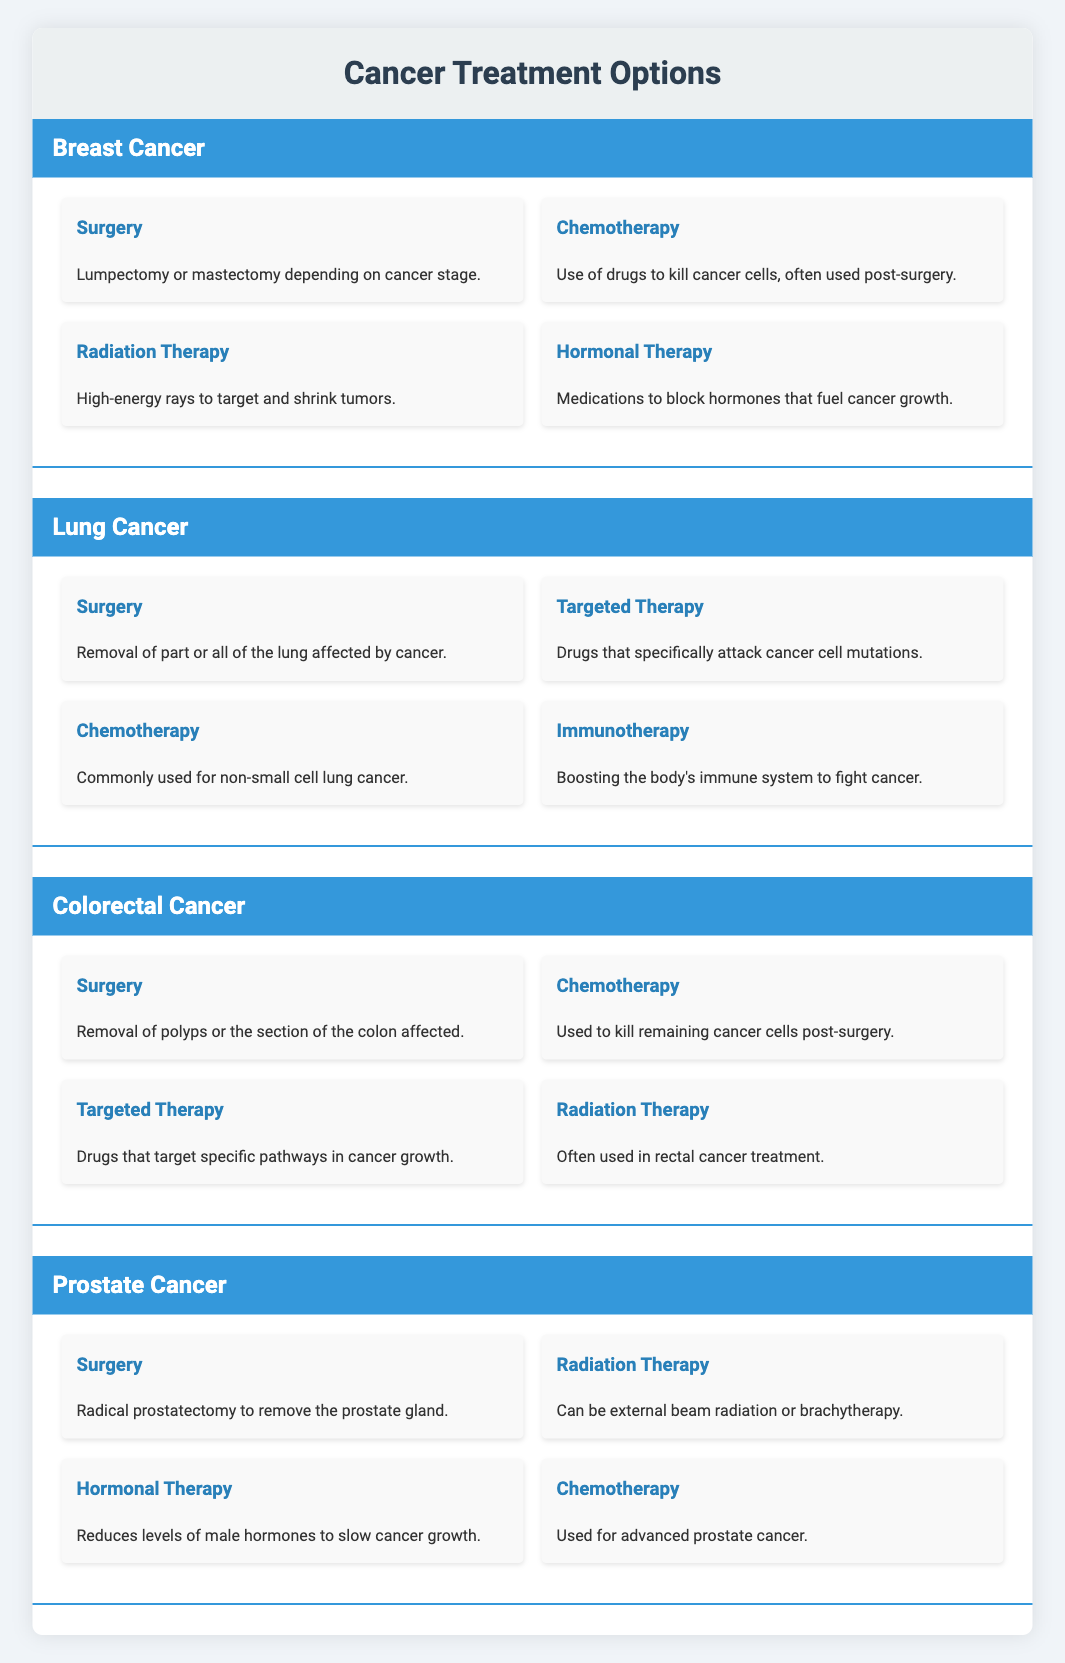What treatment options are available for Breast Cancer? The table lists four treatments under Breast Cancer: Surgery, Chemotherapy, Radiation Therapy, and Hormonal Therapy.
Answer: Surgery, Chemotherapy, Radiation Therapy, Hormonal Therapy Is Radiation Therapy included in the treatment options for Lung Cancer? Looking under the Lung Cancer section, the available treatments are Surgery, Targeted Therapy, Chemotherapy, and Immunotherapy. Radiation Therapy is not listed here, so the answer is no.
Answer: No How many treatments are listed for Colorectal Cancer? The table shows four treatments for Colorectal Cancer, which are Surgery, Chemotherapy, Targeted Therapy, and Radiation Therapy.
Answer: Four Which cancer type has immunotherapy as a treatment option? By checking the list of treatments under each cancer type, it is clear that Immunotherapy is associated with Lung Cancer only.
Answer: Lung Cancer Is Chemotherapy a treatment for both Breast Cancer and Prostate Cancer? Breast Cancer has Chemotherapy listed as a treatment, and Prostate Cancer also includes it as one of the treatment options. Therefore, the answer is yes.
Answer: Yes What is the difference in the number of treatment options between Lung Cancer and Prostate Cancer? Lung Cancer has four treatments: Surgery, Targeted Therapy, Chemotherapy, and Immunotherapy. Prostate Cancer also has four treatments: Surgery, Radiation Therapy, Hormonal Therapy, and Chemotherapy. The differences in the number of treatment options between these two cancer types is 4 - 4 = 0.
Answer: 0 Which treatment is common to both Breast Cancer and Colorectal Cancer? By reviewing the treatments listed for both cancers, Chemotherapy is mentioned in both sections, making it common to both.
Answer: Chemotherapy What are the treatment options for Prostate Cancer that do not include surgery? The Prostate Cancer treatments include Radiation Therapy, Hormonal Therapy, and Chemotherapy. Thus, the treatment options excluding surgery are these three.
Answer: Radiation Therapy, Hormonal Therapy, Chemotherapy How many treatments involve surgery across all cancer types? Each type of cancer listed in the table includes Surgery as one of the treatment options, so there are four types with surgery mentioned (Breast Cancer, Lung Cancer, Colorectal Cancer, Prostate Cancer). Hence, the total number of treatments involving surgery is 4.
Answer: 4 